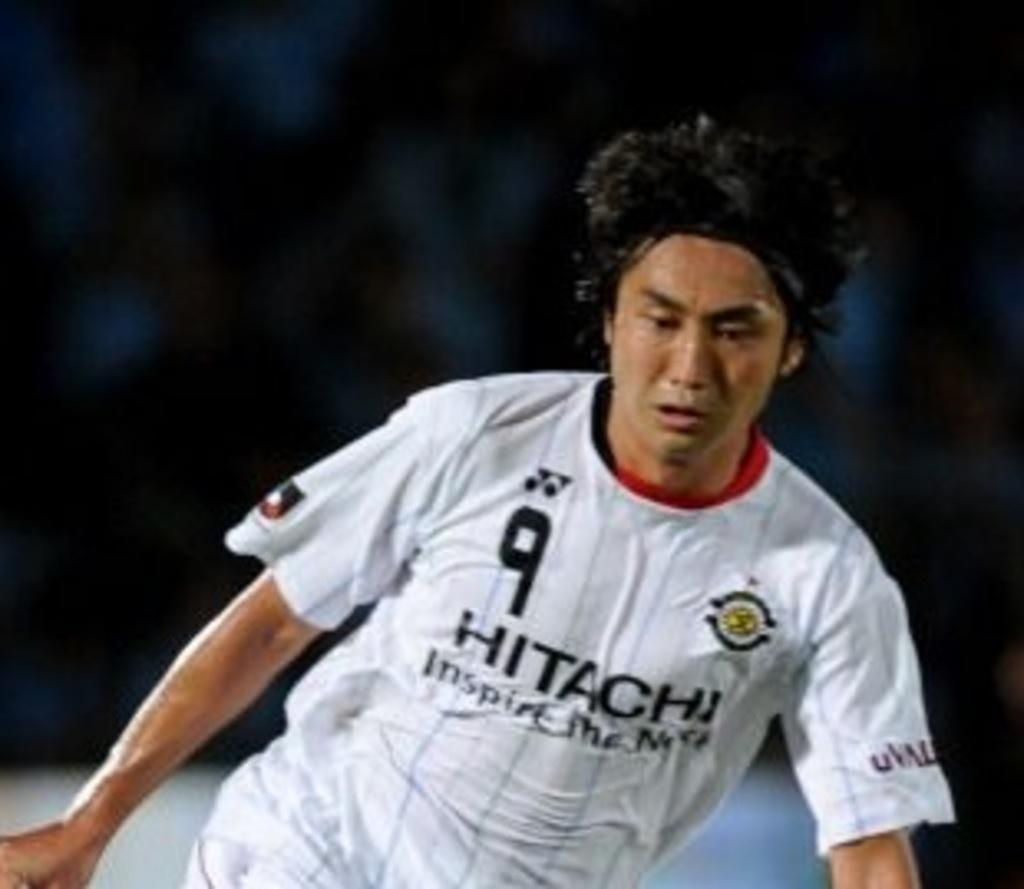<image>
Describe the image concisely. a jersey with the number 9 on their jersey 